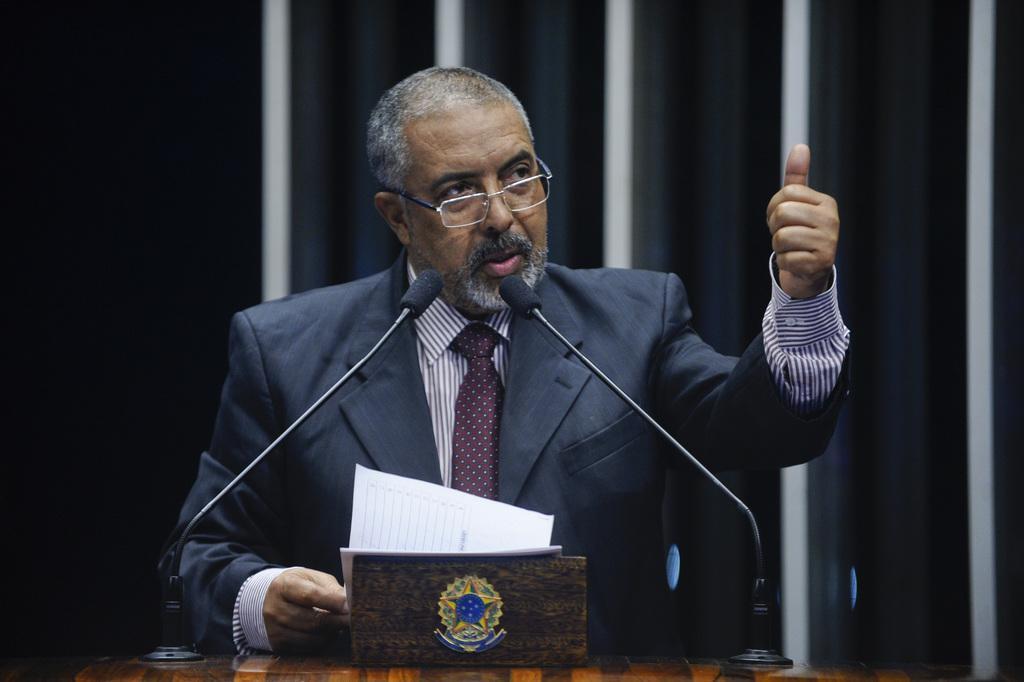In one or two sentences, can you explain what this image depicts? In this picture there is a person wearing black suit is standing and there are two mics and few papers in front of him and the background is in black and white color. 